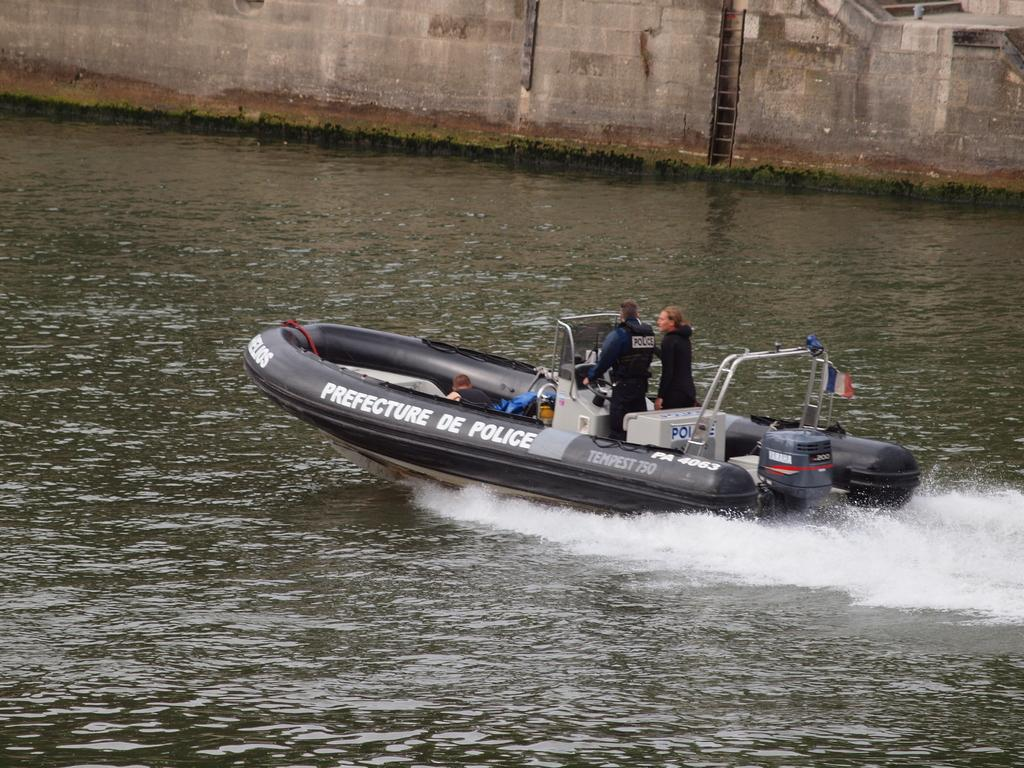What are the people in the image doing? The people in the image are in a boat. Where is the boat located? The boat is on the water. What can be seen in the background of the image? There is a wall and a ladder in the background of the image. What type of song is being sung by the people in the boat? There is no indication in the image that the people are singing, so it cannot be determined from the picture. 